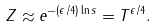<formula> <loc_0><loc_0><loc_500><loc_500>Z \approx e ^ { - ( \epsilon / 4 ) \ln s } = T ^ { \epsilon / 4 } .</formula> 